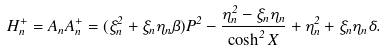<formula> <loc_0><loc_0><loc_500><loc_500>H ^ { + } _ { n } = A _ { n } A ^ { + } _ { n } = ( \xi _ { n } ^ { 2 } + \xi _ { n } \eta _ { n } \beta ) P ^ { 2 } - \frac { \eta ^ { 2 } _ { n } - \xi _ { n } \eta _ { n } } { \cosh ^ { 2 } X } + \eta _ { n } ^ { 2 } + \xi _ { n } \eta _ { n } \delta .</formula> 